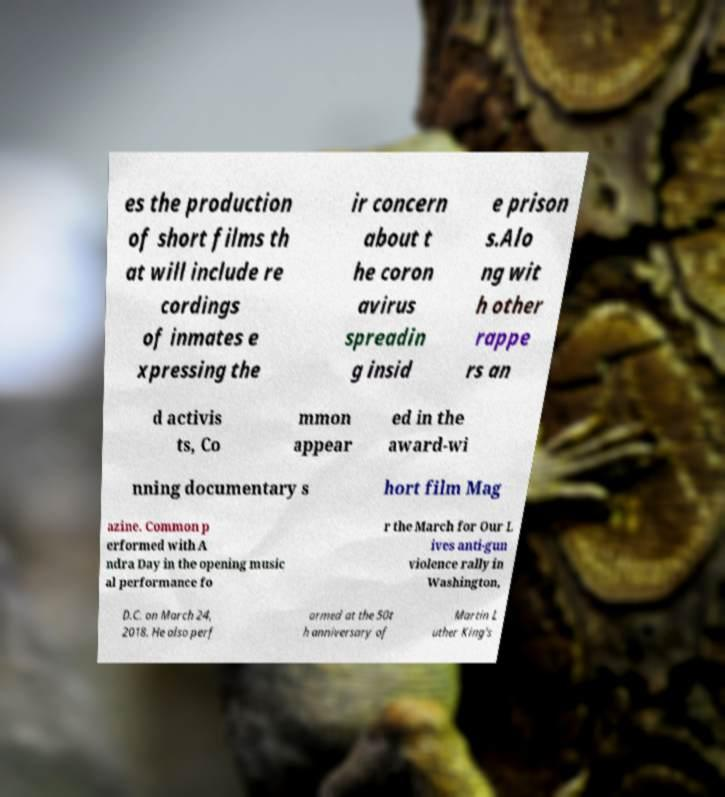Could you assist in decoding the text presented in this image and type it out clearly? es the production of short films th at will include re cordings of inmates e xpressing the ir concern about t he coron avirus spreadin g insid e prison s.Alo ng wit h other rappe rs an d activis ts, Co mmon appear ed in the award-wi nning documentary s hort film Mag azine. Common p erformed with A ndra Day in the opening music al performance fo r the March for Our L ives anti-gun violence rally in Washington, D.C. on March 24, 2018. He also perf ormed at the 50t h anniversary of Martin L uther King's 